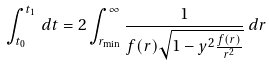Convert formula to latex. <formula><loc_0><loc_0><loc_500><loc_500>\int _ { t _ { 0 } } ^ { t _ { 1 } } \, d t = 2 \int _ { r _ { \min } } ^ { \infty } \frac { 1 } { f ( r ) \sqrt { 1 - y ^ { 2 } \frac { f ( r ) } { r ^ { 2 } } } } \, d r</formula> 